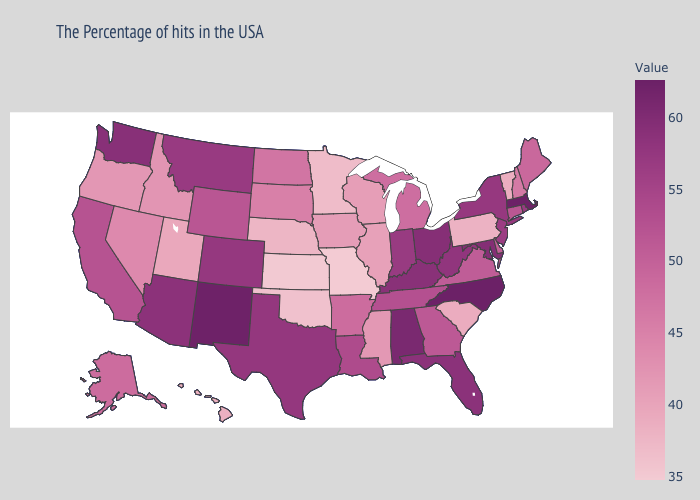Does Michigan have a lower value than Hawaii?
Short answer required. No. Which states have the highest value in the USA?
Give a very brief answer. North Carolina. Which states hav the highest value in the Northeast?
Short answer required. Massachusetts. Does Washington have a higher value than Missouri?
Give a very brief answer. Yes. Which states have the lowest value in the West?
Write a very short answer. Hawaii. 